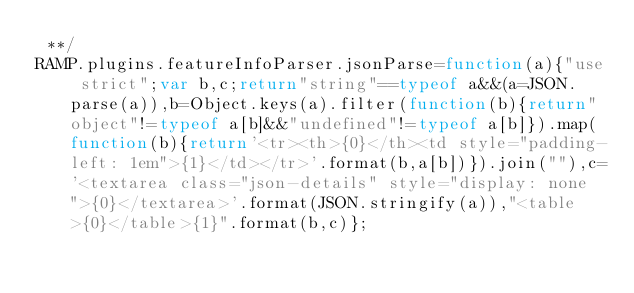Convert code to text. <code><loc_0><loc_0><loc_500><loc_500><_JavaScript_> **/
RAMP.plugins.featureInfoParser.jsonParse=function(a){"use strict";var b,c;return"string"==typeof a&&(a=JSON.parse(a)),b=Object.keys(a).filter(function(b){return"object"!=typeof a[b]&&"undefined"!=typeof a[b]}).map(function(b){return'<tr><th>{0}</th><td style="padding-left: 1em">{1}</td></tr>'.format(b,a[b])}).join(""),c='<textarea class="json-details" style="display: none">{0}</textarea>'.format(JSON.stringify(a)),"<table>{0}</table>{1}".format(b,c)};</code> 